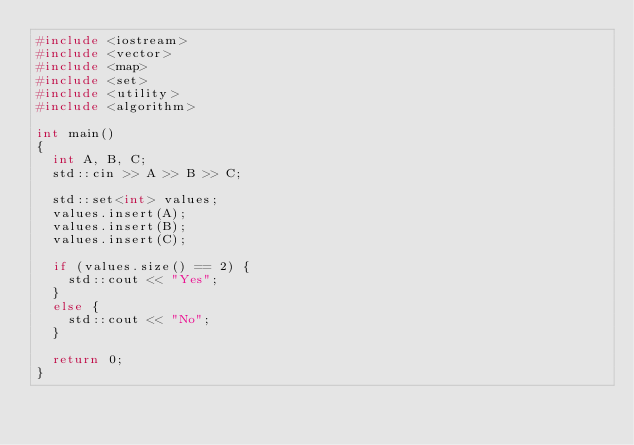Convert code to text. <code><loc_0><loc_0><loc_500><loc_500><_C++_>#include <iostream>
#include <vector>
#include <map>
#include <set>
#include <utility>
#include <algorithm>

int main()
{
	int A, B, C;
	std::cin >> A >> B >> C;

	std::set<int> values;
	values.insert(A);
	values.insert(B);
	values.insert(C);

	if (values.size() == 2) {
		std::cout << "Yes";
	}
	else {
		std::cout << "No";
	}
	
	return 0;
}</code> 